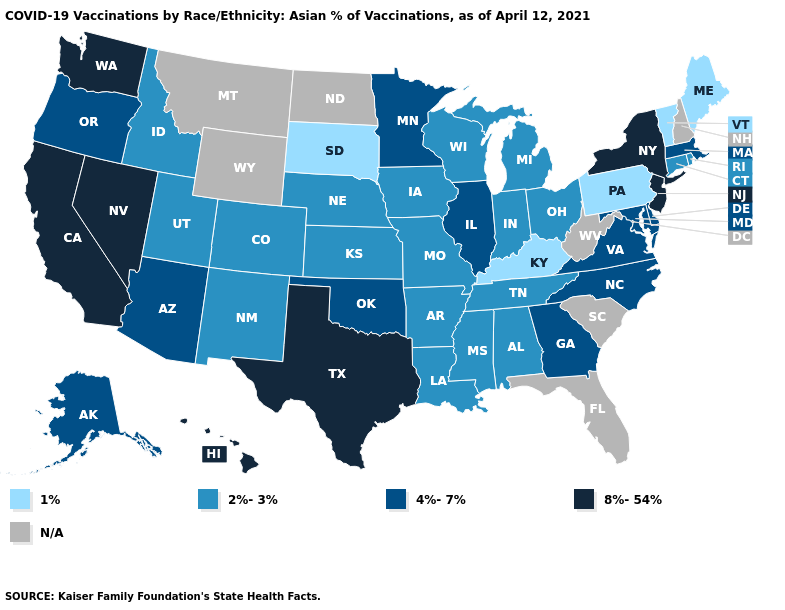Does the first symbol in the legend represent the smallest category?
Give a very brief answer. Yes. Does the first symbol in the legend represent the smallest category?
Give a very brief answer. Yes. Does Hawaii have the highest value in the West?
Write a very short answer. Yes. Name the states that have a value in the range 8%-54%?
Concise answer only. California, Hawaii, Nevada, New Jersey, New York, Texas, Washington. What is the value of Tennessee?
Write a very short answer. 2%-3%. Which states have the highest value in the USA?
Short answer required. California, Hawaii, Nevada, New Jersey, New York, Texas, Washington. What is the value of Kentucky?
Concise answer only. 1%. What is the value of Alaska?
Quick response, please. 4%-7%. Name the states that have a value in the range 8%-54%?
Short answer required. California, Hawaii, Nevada, New Jersey, New York, Texas, Washington. What is the lowest value in the MidWest?
Answer briefly. 1%. What is the value of Louisiana?
Be succinct. 2%-3%. Among the states that border Vermont , does New York have the highest value?
Answer briefly. Yes. Which states have the lowest value in the USA?
Give a very brief answer. Kentucky, Maine, Pennsylvania, South Dakota, Vermont. Name the states that have a value in the range 2%-3%?
Keep it brief. Alabama, Arkansas, Colorado, Connecticut, Idaho, Indiana, Iowa, Kansas, Louisiana, Michigan, Mississippi, Missouri, Nebraska, New Mexico, Ohio, Rhode Island, Tennessee, Utah, Wisconsin. Does New Jersey have the highest value in the Northeast?
Give a very brief answer. Yes. 